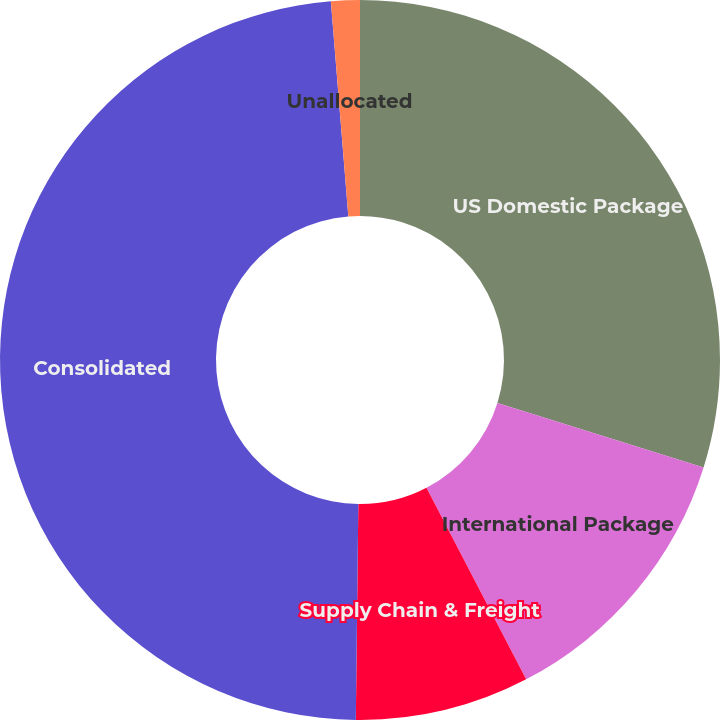Convert chart to OTSL. <chart><loc_0><loc_0><loc_500><loc_500><pie_chart><fcel>US Domestic Package<fcel>International Package<fcel>Supply Chain & Freight<fcel>Consolidated<fcel>Unallocated<nl><fcel>29.82%<fcel>12.54%<fcel>7.82%<fcel>48.52%<fcel>1.29%<nl></chart> 